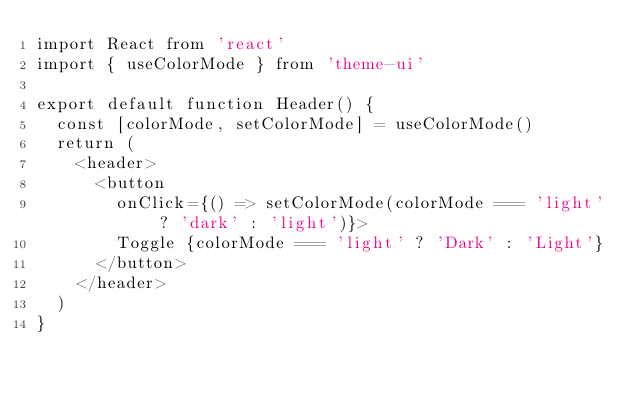<code> <loc_0><loc_0><loc_500><loc_500><_JavaScript_>import React from 'react'
import { useColorMode } from 'theme-ui'

export default function Header() {
  const [colorMode, setColorMode] = useColorMode()
  return (
    <header>
      <button
        onClick={() => setColorMode(colorMode === 'light' ? 'dark' : 'light')}>
        Toggle {colorMode === 'light' ? 'Dark' : 'Light'}
      </button>
    </header>
  )
}
</code> 